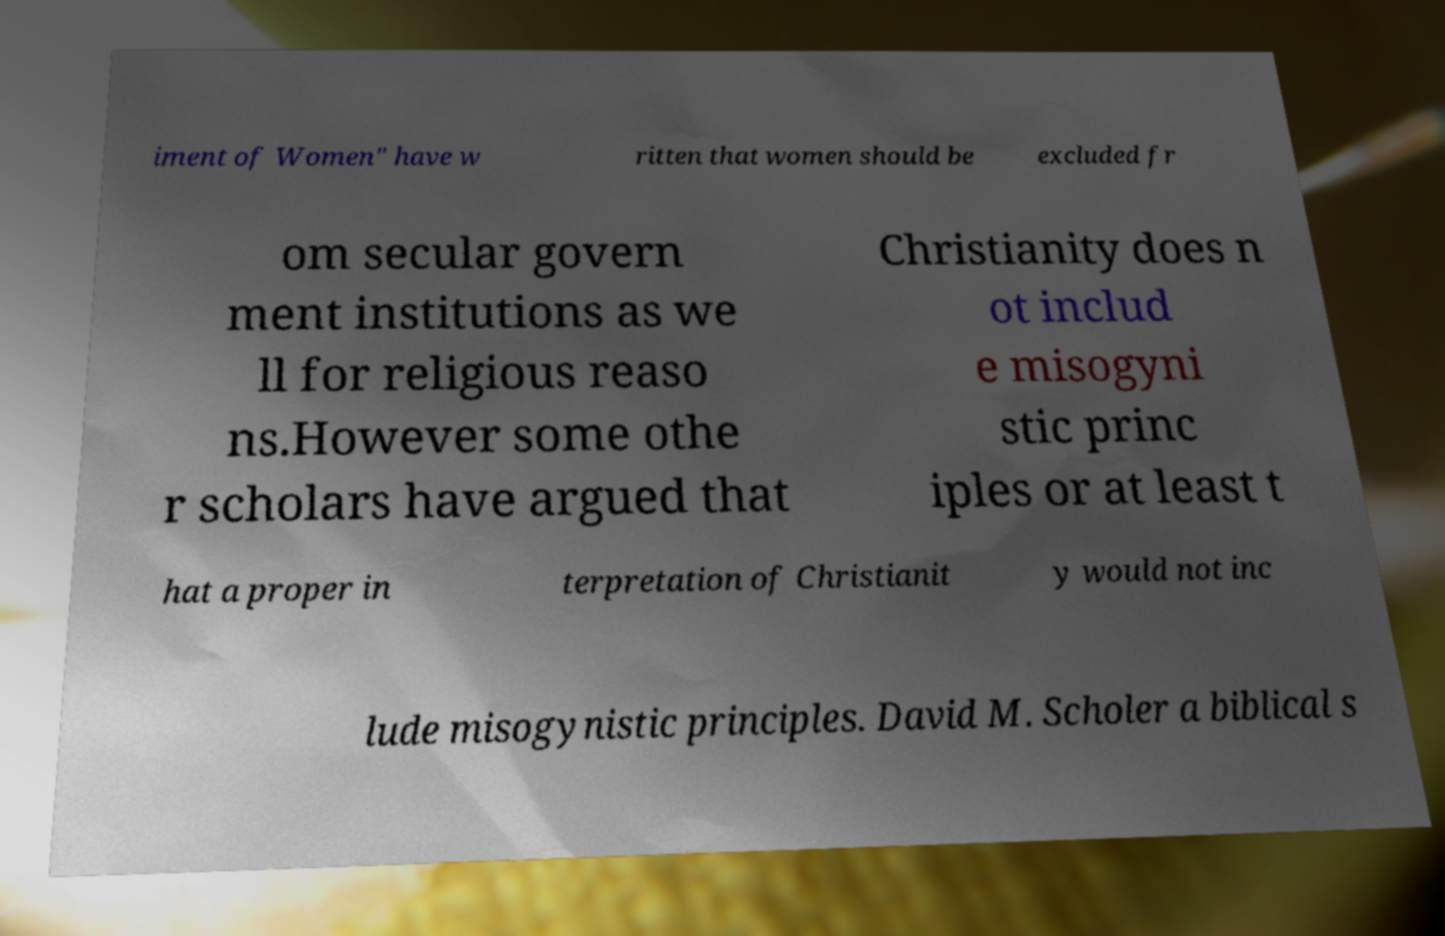For documentation purposes, I need the text within this image transcribed. Could you provide that? iment of Women" have w ritten that women should be excluded fr om secular govern ment institutions as we ll for religious reaso ns.However some othe r scholars have argued that Christianity does n ot includ e misogyni stic princ iples or at least t hat a proper in terpretation of Christianit y would not inc lude misogynistic principles. David M. Scholer a biblical s 